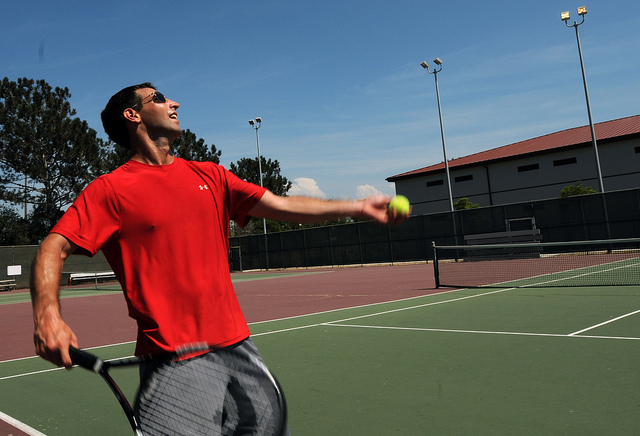<image>Is this man a professional tennis player? I don't know if this man is a professional tennis player. The answer can be yes or no. How is the building designed? I don't know how the building is designed. It can be two story, square, rectangular, or other styles depending on the actual situation. What year was this taken in? It is unclear what year this was taken in. The answers range from 2000 to 2016. Is this man a professional tennis player? Maybe I don't know if this man is a professional tennis player. How is the building designed? I don't know how the building is designed. It can have a sloped roof, be two story, low, rectangular, square, or have a Wright design. What year was this taken in? It is uncertain what year was this taken in. It can be any of '2015', '2012', '2010', '2000', '2016', or '2013'. 